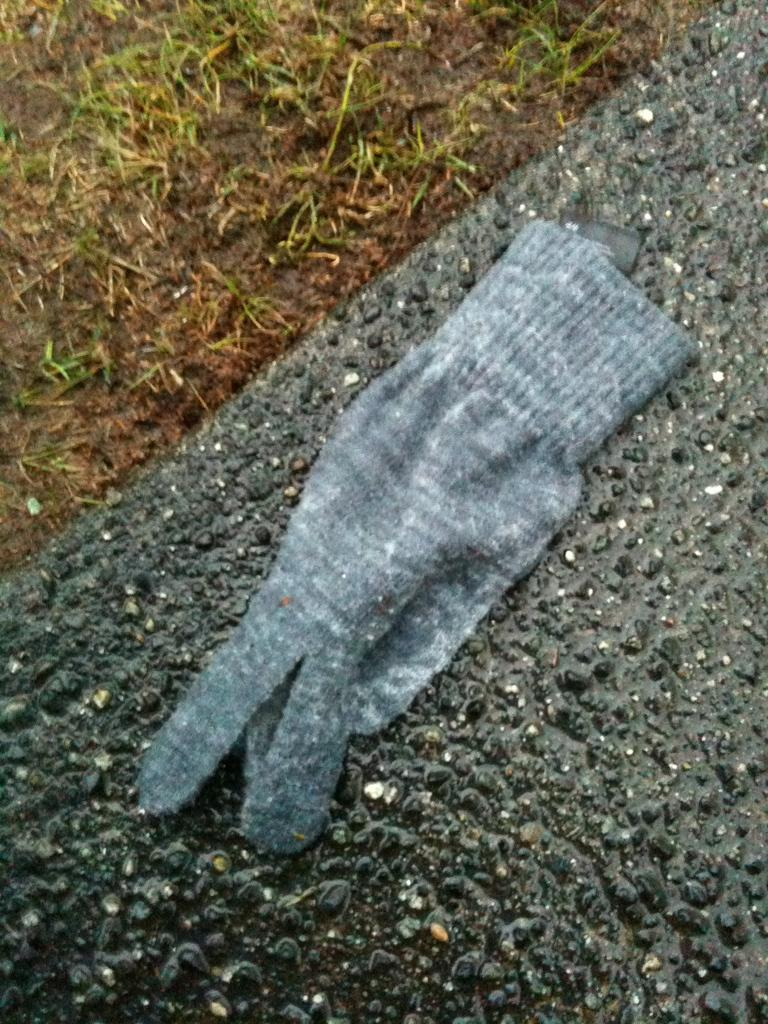What color is the glove in the image? The glove is grey in color. Where is the glove located in the image? The glove is on a surface. What type of vegetation can be seen in the image? Green grass is visible in the image. What historical event is depicted in the image involving the cup? There is no cup present in the image, and therefore no historical event involving a cup can be observed. 